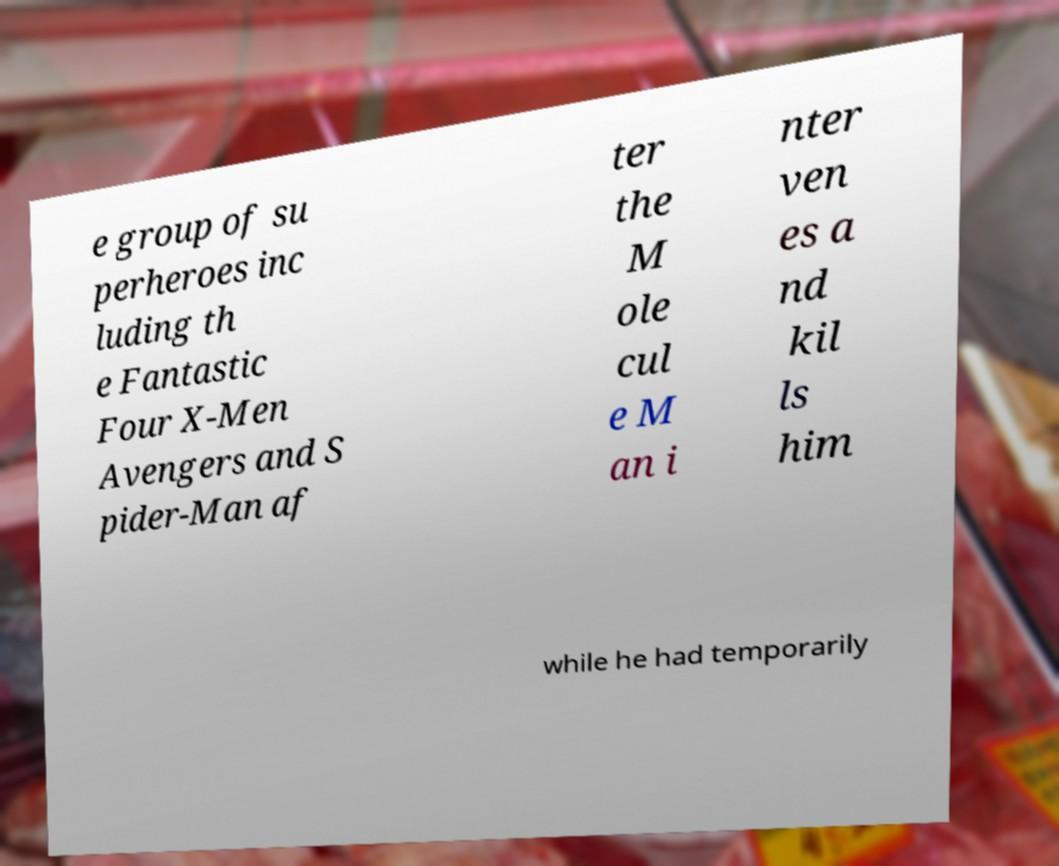Please read and relay the text visible in this image. What does it say? e group of su perheroes inc luding th e Fantastic Four X-Men Avengers and S pider-Man af ter the M ole cul e M an i nter ven es a nd kil ls him while he had temporarily 